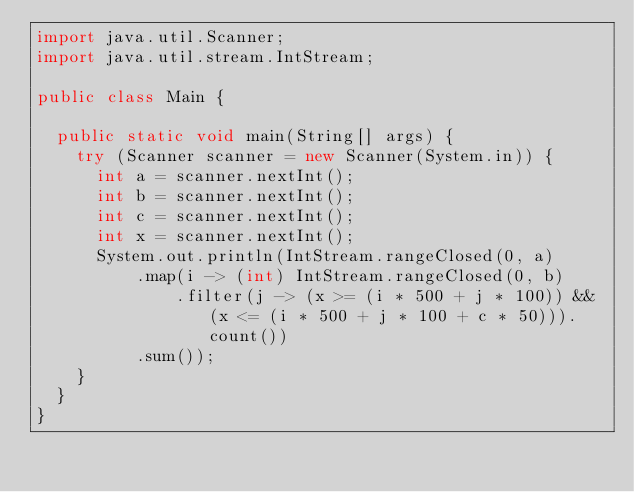<code> <loc_0><loc_0><loc_500><loc_500><_Java_>import java.util.Scanner;
import java.util.stream.IntStream;

public class Main {

	public static void main(String[] args) {
		try (Scanner scanner = new Scanner(System.in)) {
			int a = scanner.nextInt();
			int b = scanner.nextInt();
			int c = scanner.nextInt();
			int x = scanner.nextInt();
			System.out.println(IntStream.rangeClosed(0, a)
					.map(i -> (int) IntStream.rangeClosed(0, b)
							.filter(j -> (x >= (i * 500 + j * 100)) && (x <= (i * 500 + j * 100 + c * 50))).count())
					.sum());
		}
	}
}
</code> 